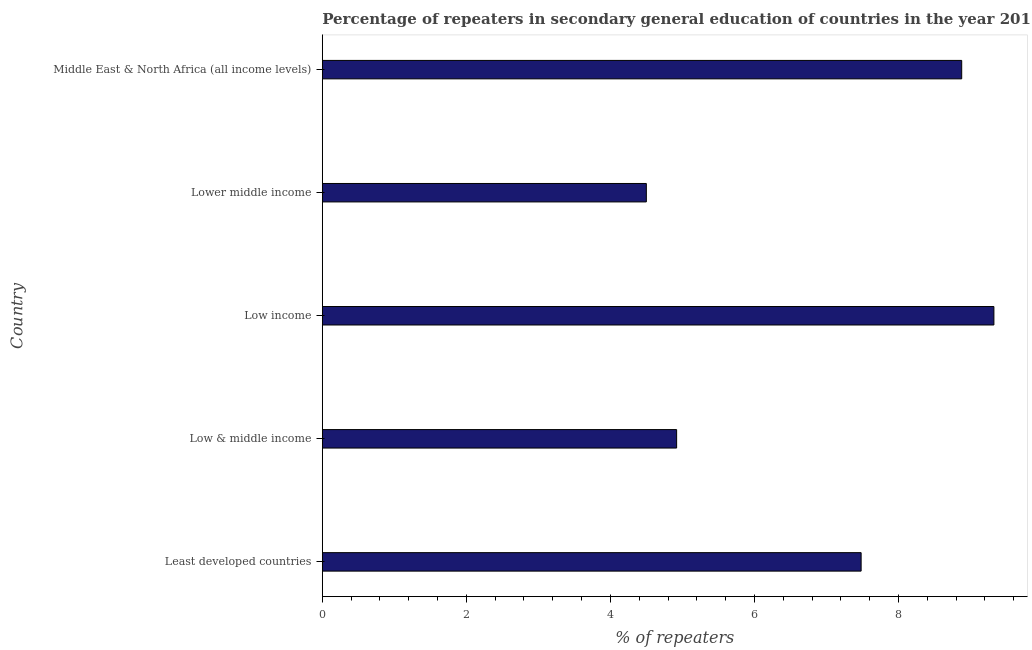Does the graph contain grids?
Provide a short and direct response. No. What is the title of the graph?
Keep it short and to the point. Percentage of repeaters in secondary general education of countries in the year 2011. What is the label or title of the X-axis?
Ensure brevity in your answer.  % of repeaters. What is the label or title of the Y-axis?
Give a very brief answer. Country. What is the percentage of repeaters in Low income?
Provide a succinct answer. 9.33. Across all countries, what is the maximum percentage of repeaters?
Ensure brevity in your answer.  9.33. Across all countries, what is the minimum percentage of repeaters?
Ensure brevity in your answer.  4.5. In which country was the percentage of repeaters maximum?
Provide a succinct answer. Low income. In which country was the percentage of repeaters minimum?
Your answer should be compact. Lower middle income. What is the sum of the percentage of repeaters?
Your answer should be very brief. 35.1. What is the difference between the percentage of repeaters in Low income and Middle East & North Africa (all income levels)?
Provide a succinct answer. 0.45. What is the average percentage of repeaters per country?
Ensure brevity in your answer.  7.02. What is the median percentage of repeaters?
Your answer should be compact. 7.48. What is the ratio of the percentage of repeaters in Least developed countries to that in Low income?
Provide a short and direct response. 0.8. Is the percentage of repeaters in Low income less than that in Middle East & North Africa (all income levels)?
Offer a terse response. No. What is the difference between the highest and the second highest percentage of repeaters?
Make the answer very short. 0.45. Is the sum of the percentage of repeaters in Lower middle income and Middle East & North Africa (all income levels) greater than the maximum percentage of repeaters across all countries?
Make the answer very short. Yes. What is the difference between the highest and the lowest percentage of repeaters?
Provide a short and direct response. 4.83. In how many countries, is the percentage of repeaters greater than the average percentage of repeaters taken over all countries?
Your response must be concise. 3. Are all the bars in the graph horizontal?
Offer a terse response. Yes. What is the % of repeaters of Least developed countries?
Your answer should be compact. 7.48. What is the % of repeaters in Low & middle income?
Provide a short and direct response. 4.92. What is the % of repeaters in Low income?
Ensure brevity in your answer.  9.33. What is the % of repeaters in Lower middle income?
Offer a very short reply. 4.5. What is the % of repeaters of Middle East & North Africa (all income levels)?
Provide a succinct answer. 8.88. What is the difference between the % of repeaters in Least developed countries and Low & middle income?
Your answer should be compact. 2.56. What is the difference between the % of repeaters in Least developed countries and Low income?
Make the answer very short. -1.84. What is the difference between the % of repeaters in Least developed countries and Lower middle income?
Offer a terse response. 2.98. What is the difference between the % of repeaters in Least developed countries and Middle East & North Africa (all income levels)?
Your response must be concise. -1.4. What is the difference between the % of repeaters in Low & middle income and Low income?
Make the answer very short. -4.41. What is the difference between the % of repeaters in Low & middle income and Lower middle income?
Your answer should be compact. 0.42. What is the difference between the % of repeaters in Low & middle income and Middle East & North Africa (all income levels)?
Your response must be concise. -3.96. What is the difference between the % of repeaters in Low income and Lower middle income?
Make the answer very short. 4.83. What is the difference between the % of repeaters in Low income and Middle East & North Africa (all income levels)?
Keep it short and to the point. 0.45. What is the difference between the % of repeaters in Lower middle income and Middle East & North Africa (all income levels)?
Provide a succinct answer. -4.38. What is the ratio of the % of repeaters in Least developed countries to that in Low & middle income?
Provide a short and direct response. 1.52. What is the ratio of the % of repeaters in Least developed countries to that in Low income?
Your answer should be compact. 0.8. What is the ratio of the % of repeaters in Least developed countries to that in Lower middle income?
Offer a terse response. 1.66. What is the ratio of the % of repeaters in Least developed countries to that in Middle East & North Africa (all income levels)?
Your answer should be compact. 0.84. What is the ratio of the % of repeaters in Low & middle income to that in Low income?
Provide a short and direct response. 0.53. What is the ratio of the % of repeaters in Low & middle income to that in Lower middle income?
Offer a terse response. 1.09. What is the ratio of the % of repeaters in Low & middle income to that in Middle East & North Africa (all income levels)?
Make the answer very short. 0.55. What is the ratio of the % of repeaters in Low income to that in Lower middle income?
Offer a very short reply. 2.07. What is the ratio of the % of repeaters in Lower middle income to that in Middle East & North Africa (all income levels)?
Your answer should be compact. 0.51. 